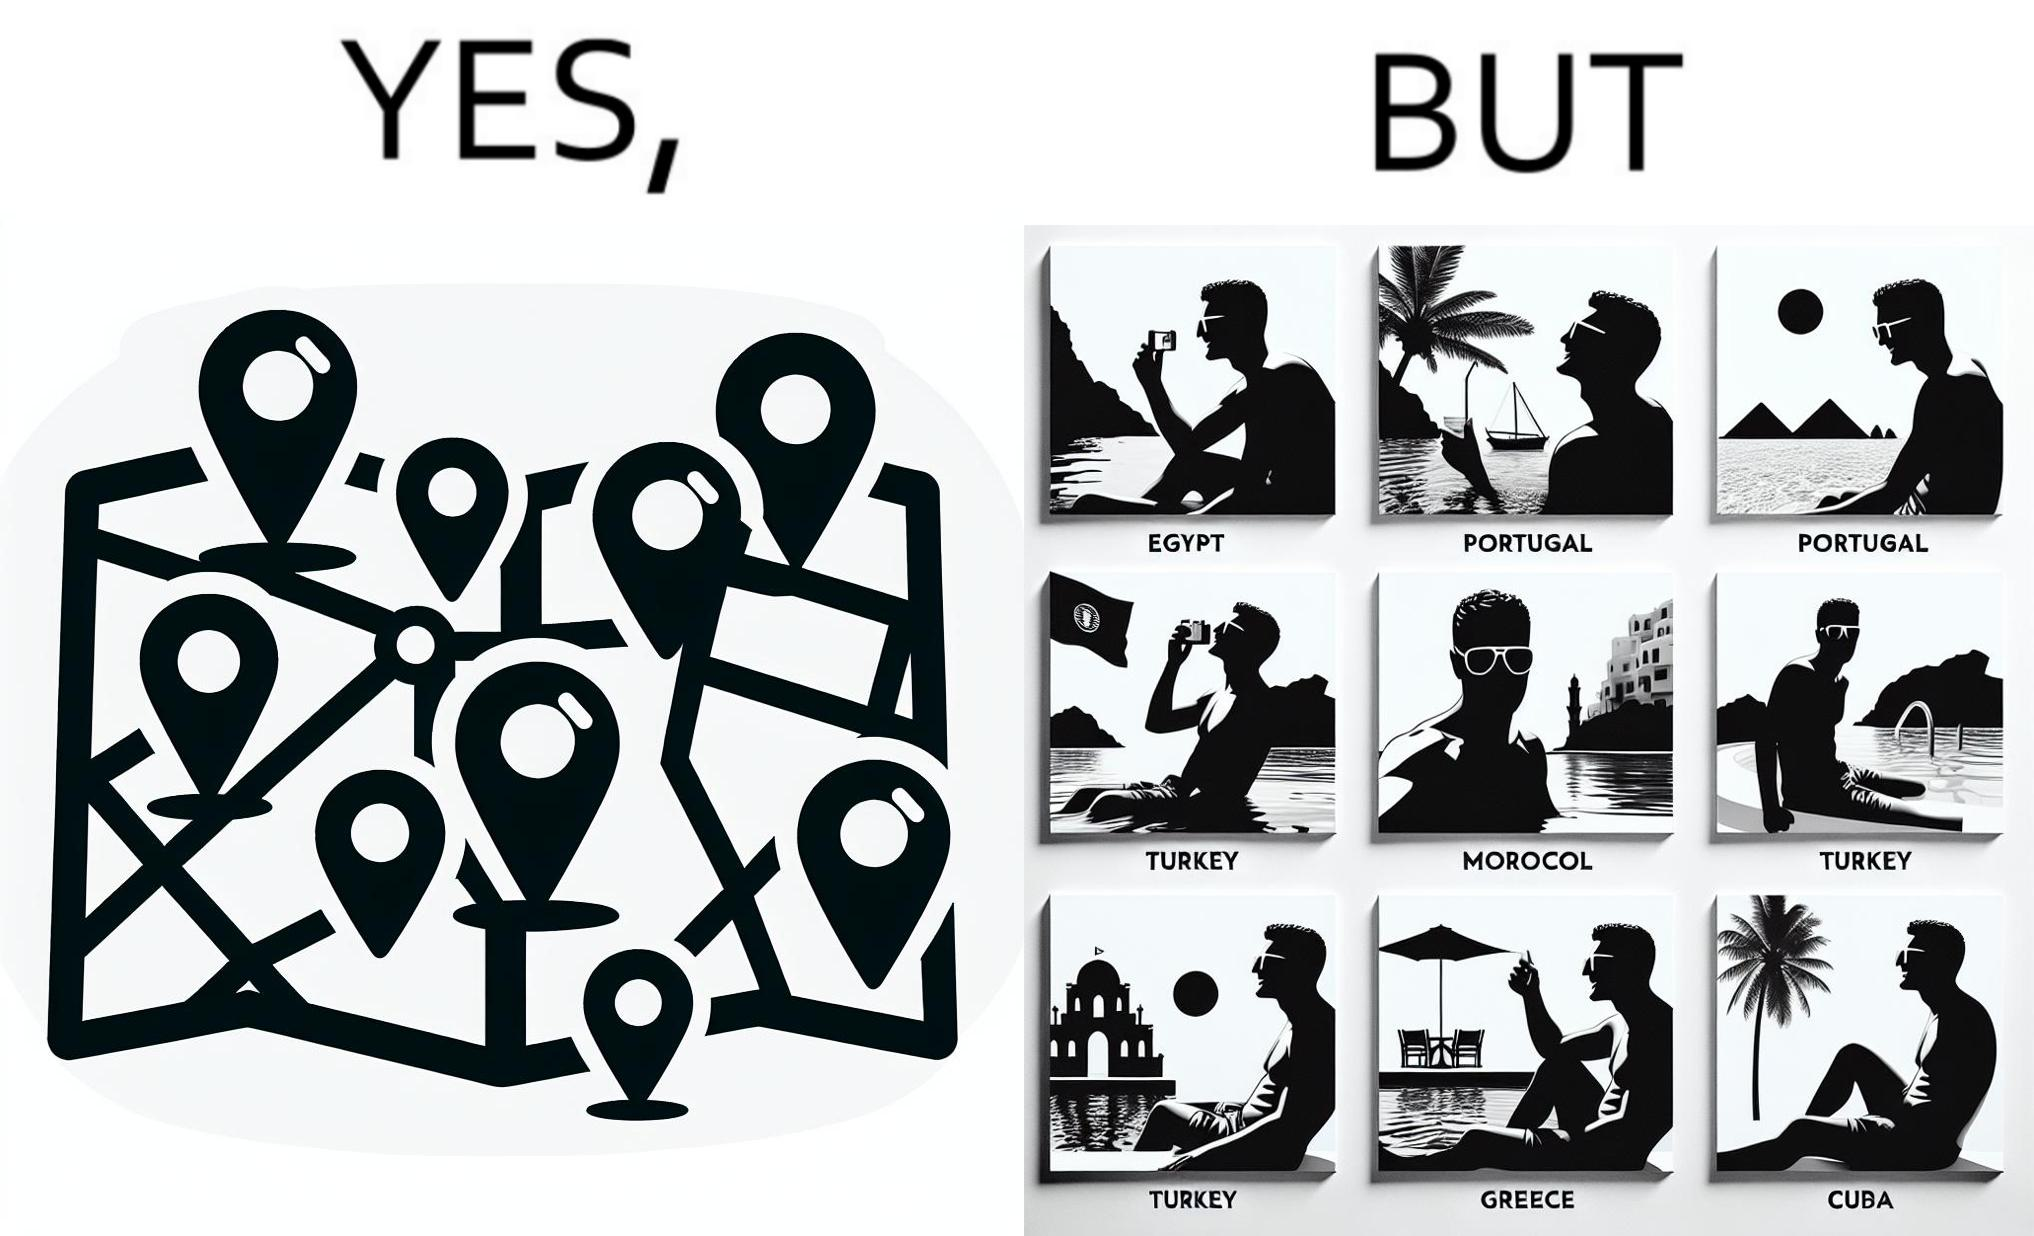Describe the contrast between the left and right parts of this image. In the left part of the image: The image shows a map with pins set on places which have been visited by a person. In the right part of the image: The image shows several photos of a man wearing sunglasses  inside a pool in various countries like Egypt, Portugal, Morocco, Turkey, Greece and Cuba. 